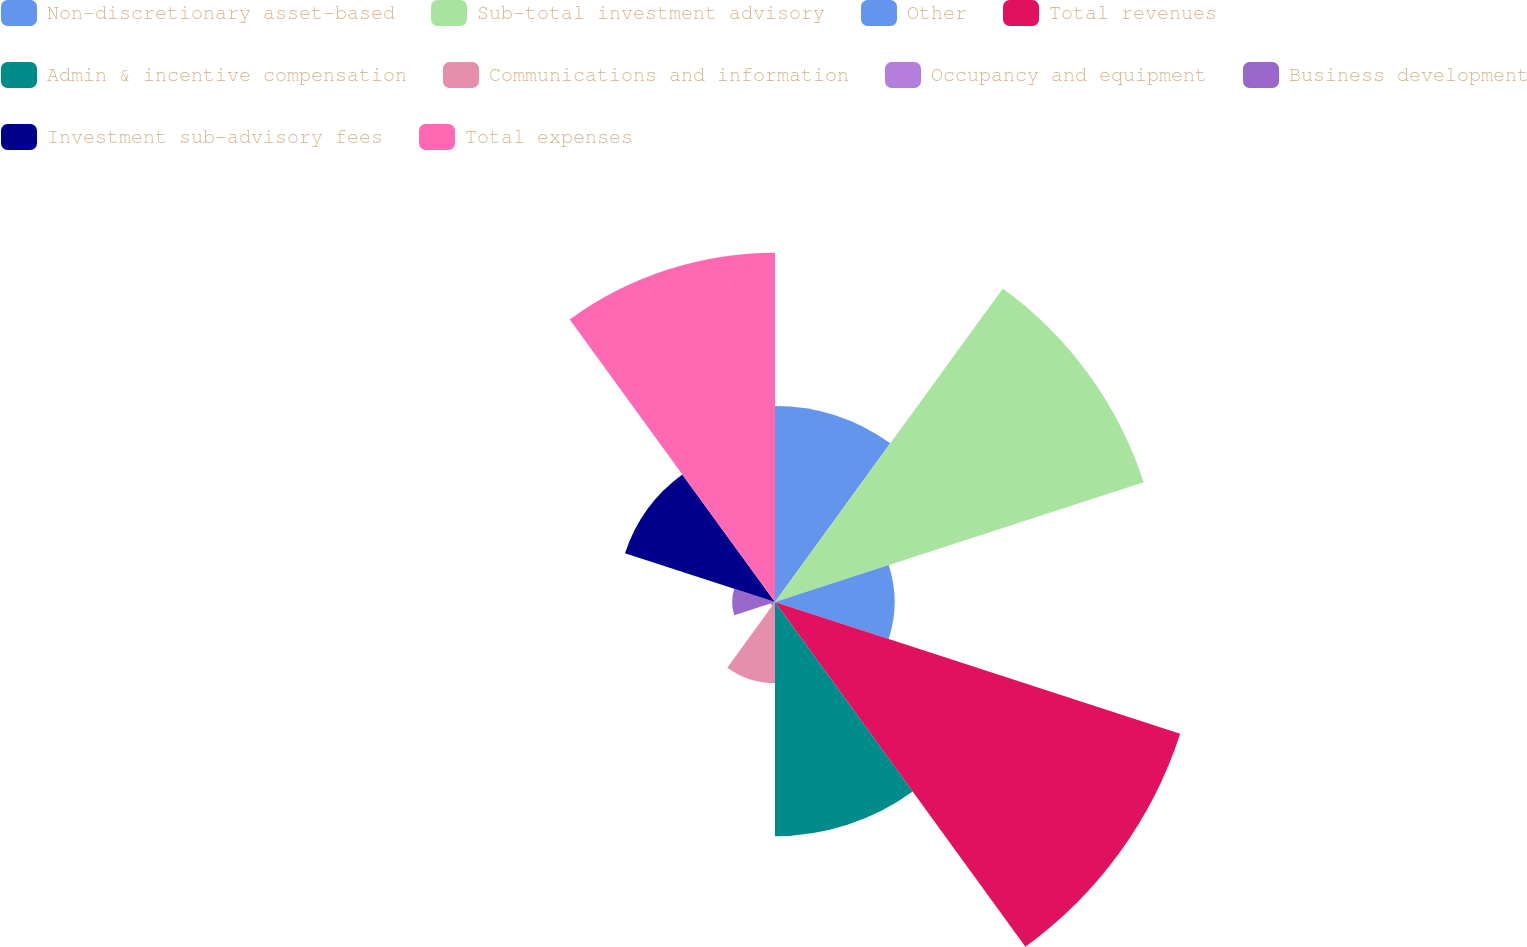Convert chart. <chart><loc_0><loc_0><loc_500><loc_500><pie_chart><fcel>Non-discretionary asset-based<fcel>Sub-total investment advisory<fcel>Other<fcel>Total revenues<fcel>Admin & incentive compensation<fcel>Communications and information<fcel>Occupancy and equipment<fcel>Business development<fcel>Investment sub-advisory fees<fcel>Total expenses<nl><fcel>9.81%<fcel>19.39%<fcel>5.98%<fcel>21.31%<fcel>11.72%<fcel>4.06%<fcel>0.23%<fcel>2.14%<fcel>7.89%<fcel>17.47%<nl></chart> 